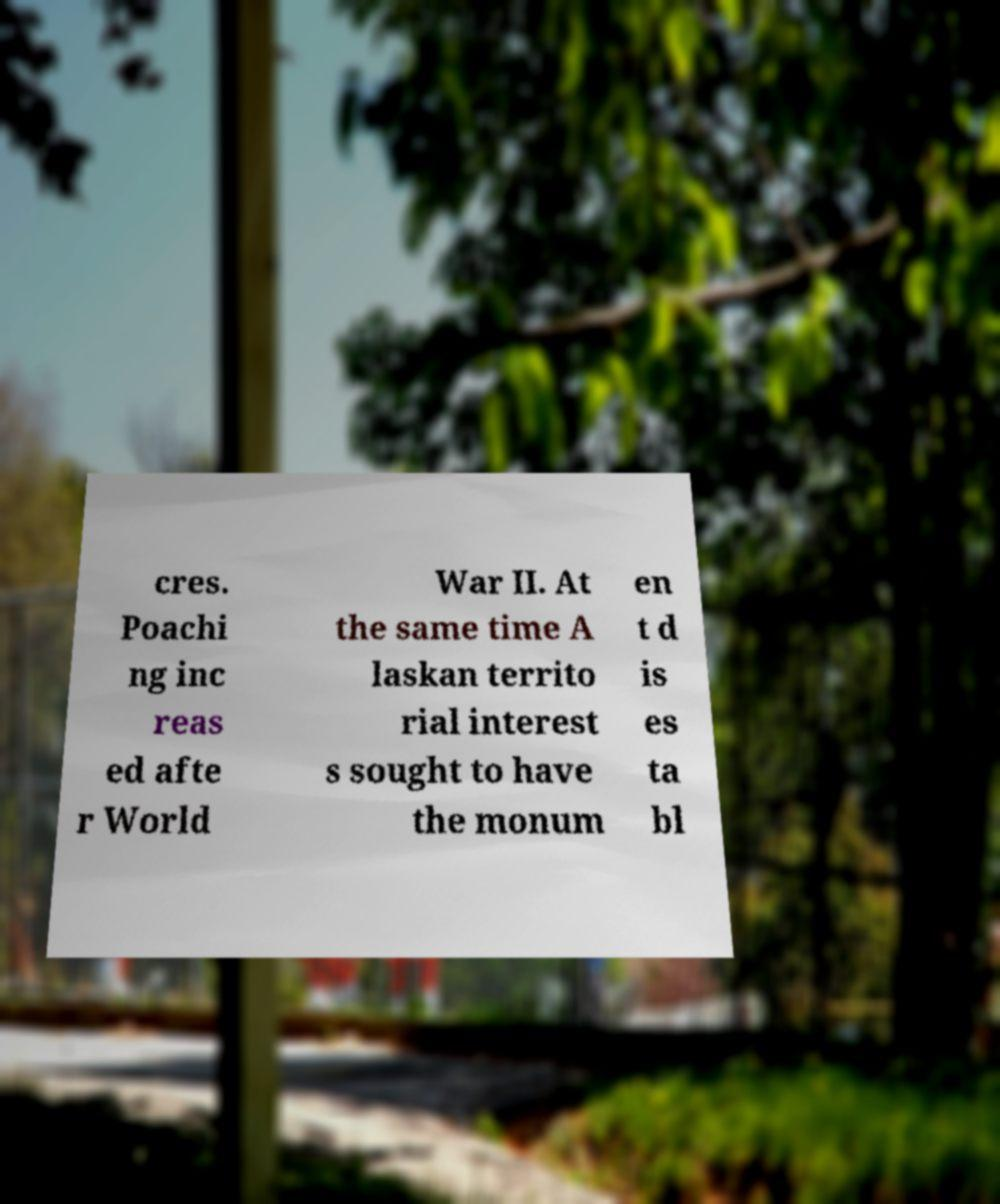Please identify and transcribe the text found in this image. cres. Poachi ng inc reas ed afte r World War II. At the same time A laskan territo rial interest s sought to have the monum en t d is es ta bl 